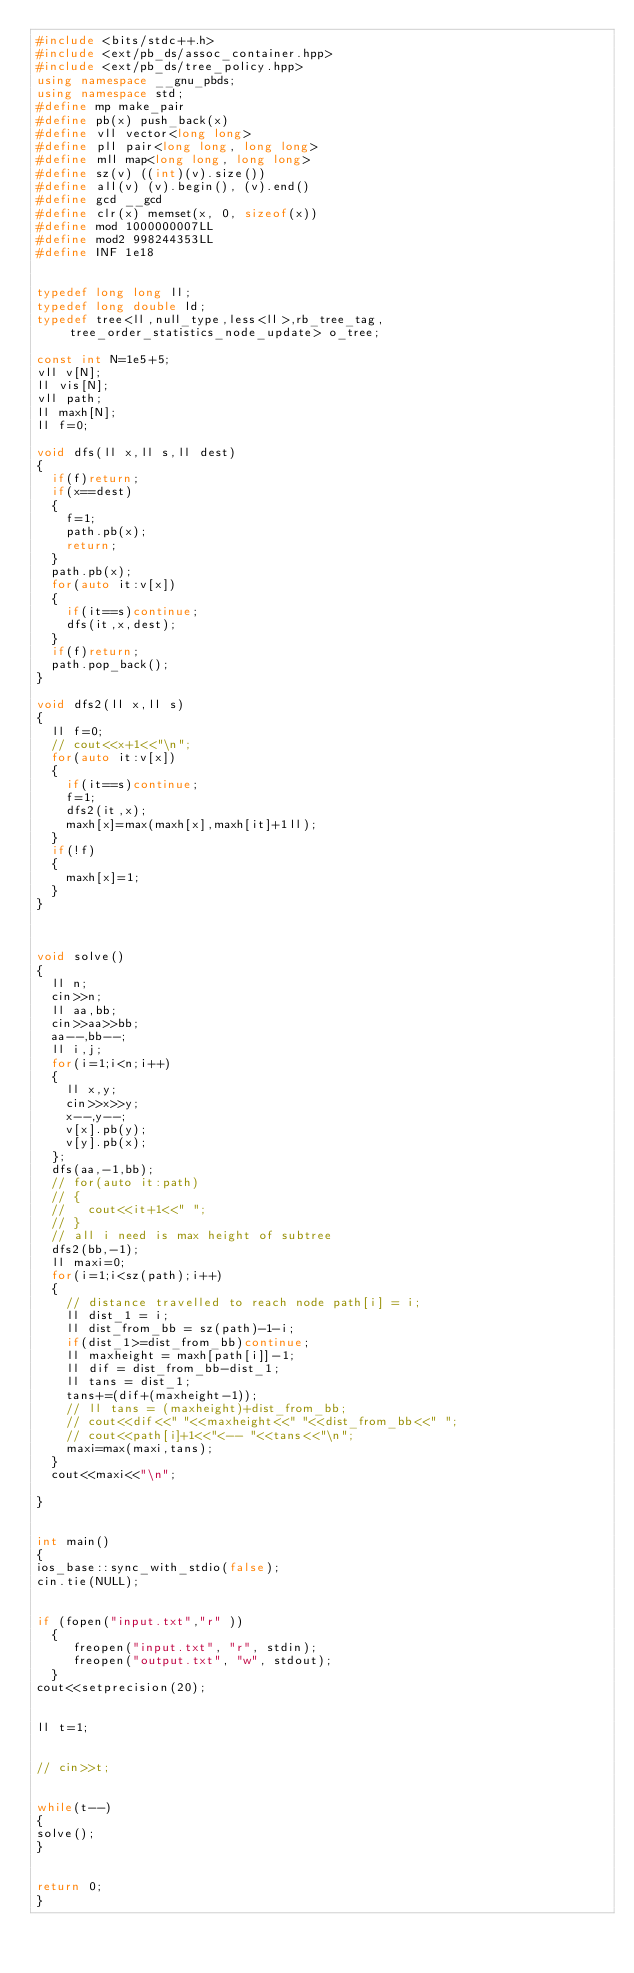<code> <loc_0><loc_0><loc_500><loc_500><_C++_>#include <bits/stdc++.h>
#include <ext/pb_ds/assoc_container.hpp>
#include <ext/pb_ds/tree_policy.hpp>
using namespace __gnu_pbds;
using namespace std;
#define mp make_pair
#define pb(x) push_back(x)
#define vll vector<long long>
#define pll pair<long long, long long>
#define mll map<long long, long long>
#define sz(v) ((int)(v).size())
#define all(v) (v).begin(), (v).end()
#define gcd __gcd
#define clr(x) memset(x, 0, sizeof(x))
#define mod 1000000007LL
#define mod2 998244353LL
#define INF 1e18
 

typedef long long ll;
typedef long double ld;
typedef tree<ll,null_type,less<ll>,rb_tree_tag,tree_order_statistics_node_update> o_tree;

const int N=1e5+5;
vll v[N];
ll vis[N];
vll path;
ll maxh[N];
ll f=0;

void dfs(ll x,ll s,ll dest)
{
  if(f)return;
  if(x==dest)
  {
    f=1;
    path.pb(x);
    return;
  }
  path.pb(x);
  for(auto it:v[x])
  {
    if(it==s)continue;
    dfs(it,x,dest);
  }
  if(f)return;
  path.pop_back();
}

void dfs2(ll x,ll s)
{
  ll f=0;
  // cout<<x+1<<"\n";
  for(auto it:v[x])
  {
    if(it==s)continue;
    f=1;
    dfs2(it,x);
    maxh[x]=max(maxh[x],maxh[it]+1ll);
  }
  if(!f)
  {
    maxh[x]=1;
  }
}



void solve()
{
  ll n;
  cin>>n;
  ll aa,bb;
  cin>>aa>>bb;
  aa--,bb--;
  ll i,j;
  for(i=1;i<n;i++)
  {
    ll x,y;
    cin>>x>>y;
    x--,y--;
    v[x].pb(y);
    v[y].pb(x);
  };
  dfs(aa,-1,bb);
  // for(auto it:path)
  // {
  //   cout<<it+1<<" ";
  // }
  // all i need is max height of subtree 
  dfs2(bb,-1);
  ll maxi=0;
  for(i=1;i<sz(path);i++)
  {
    // distance travelled to reach node path[i] = i; 
    ll dist_1 = i;
    ll dist_from_bb = sz(path)-1-i;
    if(dist_1>=dist_from_bb)continue;
    ll maxheight = maxh[path[i]]-1;
    ll dif = dist_from_bb-dist_1;
    ll tans = dist_1;
    tans+=(dif+(maxheight-1));
    // ll tans = (maxheight)+dist_from_bb;
    // cout<<dif<<" "<<maxheight<<" "<<dist_from_bb<<" ";
    // cout<<path[i]+1<<"<-- "<<tans<<"\n";
    maxi=max(maxi,tans);
  }
  cout<<maxi<<"\n";
  
}


int main()
{
ios_base::sync_with_stdio(false);
cin.tie(NULL);


if (fopen("input.txt","r" ))
  {
     freopen("input.txt", "r", stdin);
     freopen("output.txt", "w", stdout);
  }
cout<<setprecision(20);


ll t=1;


// cin>>t;


while(t--)
{
solve();
} 


return 0;
}</code> 